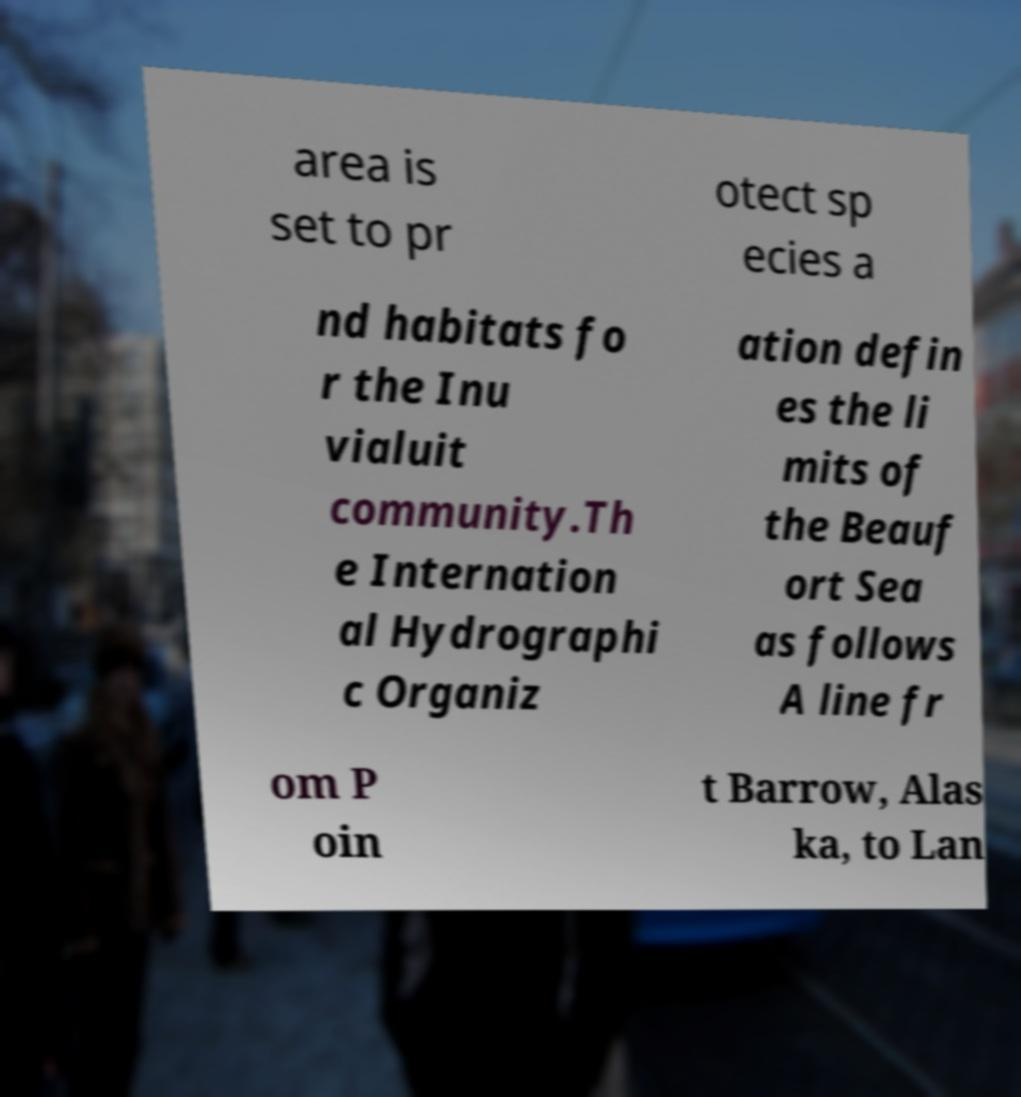What messages or text are displayed in this image? I need them in a readable, typed format. area is set to pr otect sp ecies a nd habitats fo r the Inu vialuit community.Th e Internation al Hydrographi c Organiz ation defin es the li mits of the Beauf ort Sea as follows A line fr om P oin t Barrow, Alas ka, to Lan 